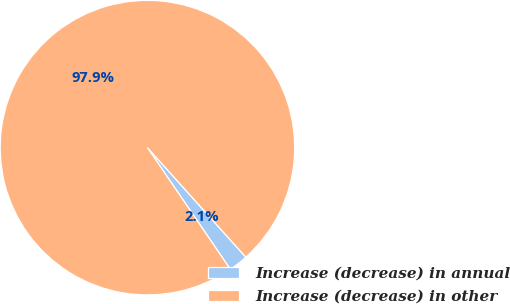Convert chart to OTSL. <chart><loc_0><loc_0><loc_500><loc_500><pie_chart><fcel>Increase (decrease) in annual<fcel>Increase (decrease) in other<nl><fcel>2.13%<fcel>97.87%<nl></chart> 